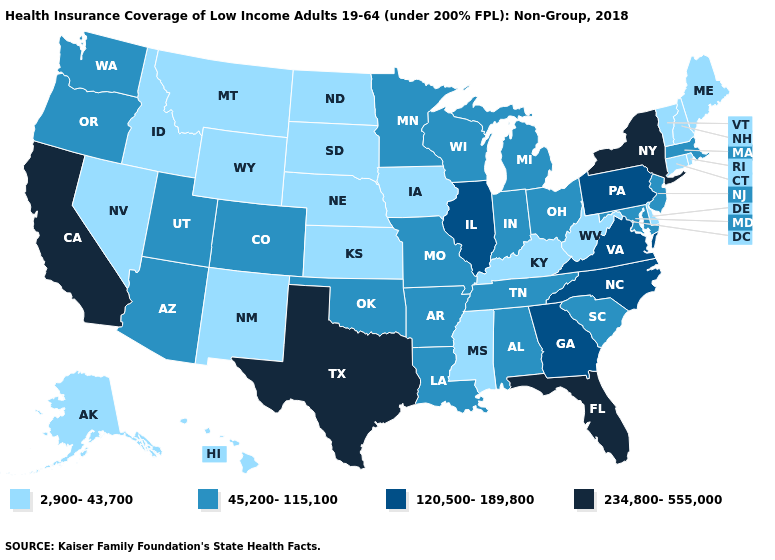Does Utah have the lowest value in the West?
Write a very short answer. No. Does the first symbol in the legend represent the smallest category?
Quick response, please. Yes. Does the first symbol in the legend represent the smallest category?
Quick response, please. Yes. Among the states that border Mississippi , which have the lowest value?
Quick response, please. Alabama, Arkansas, Louisiana, Tennessee. Does Louisiana have the same value as Wyoming?
Concise answer only. No. What is the value of Iowa?
Give a very brief answer. 2,900-43,700. Is the legend a continuous bar?
Be succinct. No. What is the lowest value in the USA?
Answer briefly. 2,900-43,700. Does Indiana have a higher value than Arizona?
Be succinct. No. What is the highest value in the Northeast ?
Give a very brief answer. 234,800-555,000. Name the states that have a value in the range 2,900-43,700?
Keep it brief. Alaska, Connecticut, Delaware, Hawaii, Idaho, Iowa, Kansas, Kentucky, Maine, Mississippi, Montana, Nebraska, Nevada, New Hampshire, New Mexico, North Dakota, Rhode Island, South Dakota, Vermont, West Virginia, Wyoming. What is the lowest value in states that border Delaware?
Concise answer only. 45,200-115,100. Name the states that have a value in the range 2,900-43,700?
Be succinct. Alaska, Connecticut, Delaware, Hawaii, Idaho, Iowa, Kansas, Kentucky, Maine, Mississippi, Montana, Nebraska, Nevada, New Hampshire, New Mexico, North Dakota, Rhode Island, South Dakota, Vermont, West Virginia, Wyoming. What is the lowest value in states that border Arkansas?
Give a very brief answer. 2,900-43,700. Among the states that border Iowa , which have the lowest value?
Short answer required. Nebraska, South Dakota. 